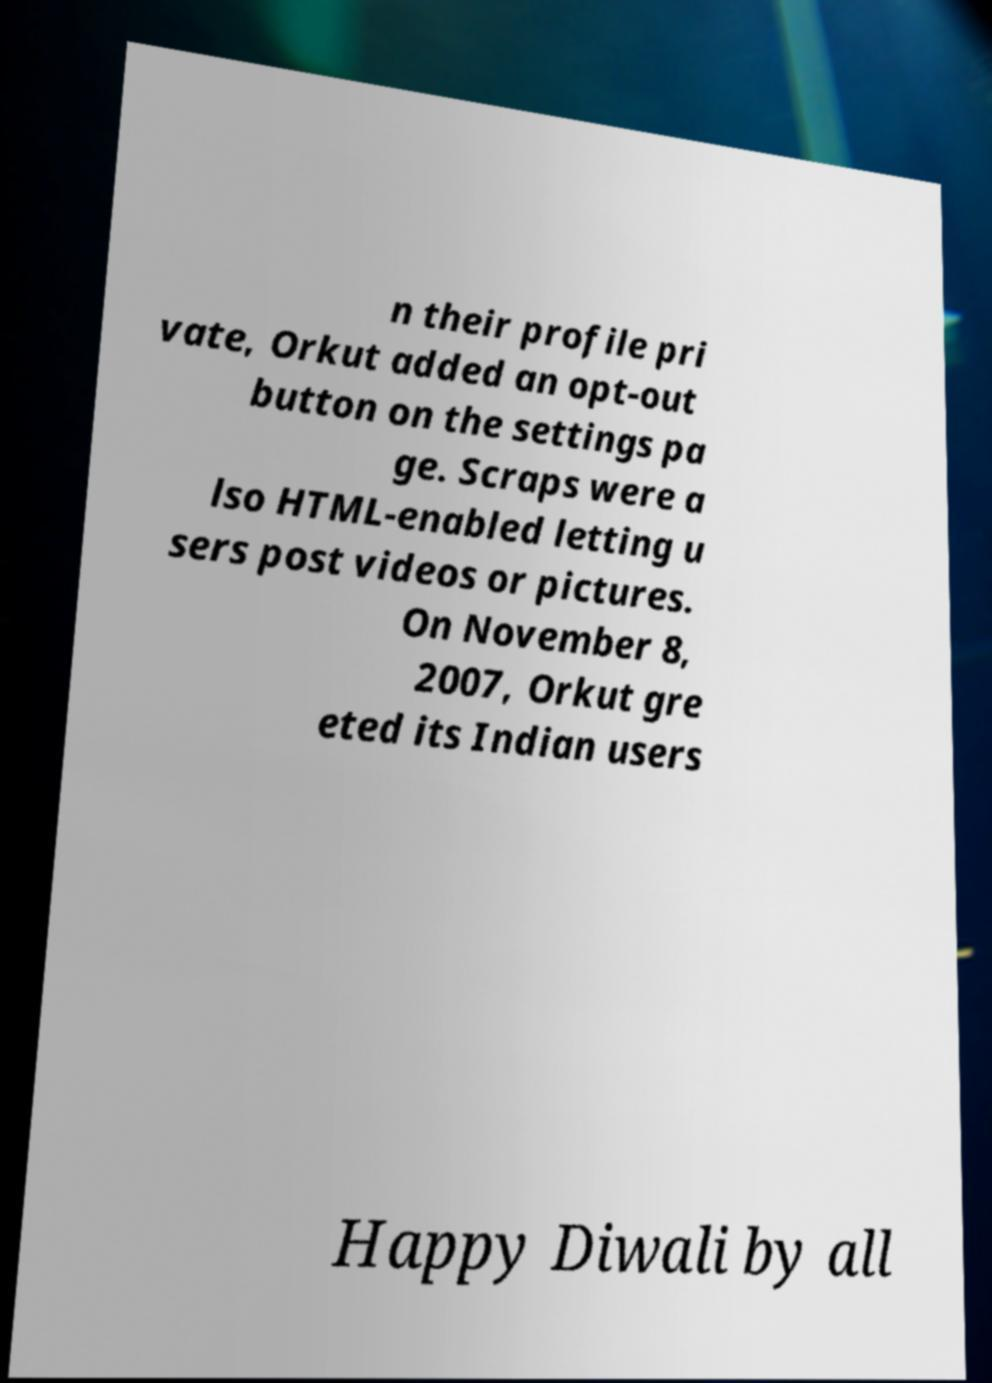For documentation purposes, I need the text within this image transcribed. Could you provide that? n their profile pri vate, Orkut added an opt-out button on the settings pa ge. Scraps were a lso HTML-enabled letting u sers post videos or pictures. On November 8, 2007, Orkut gre eted its Indian users Happy Diwali by all 